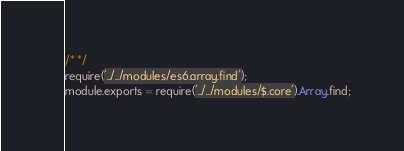Convert code to text. <code><loc_0><loc_0><loc_500><loc_500><_JavaScript_>/* */ 
require('../../modules/es6.array.find');
module.exports = require('../../modules/$.core').Array.find;
</code> 